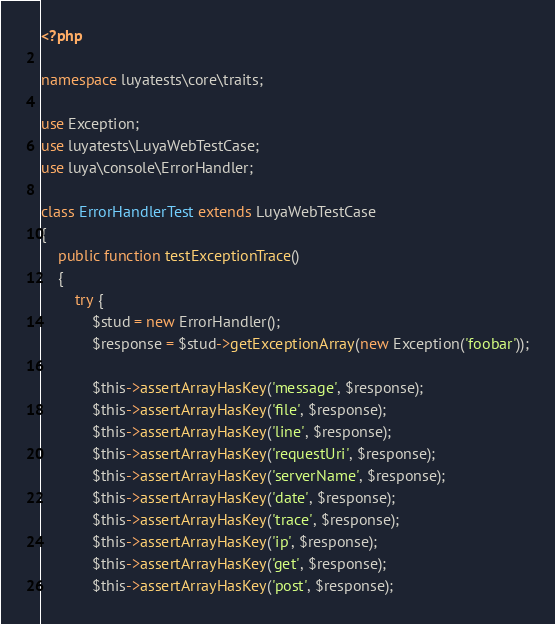Convert code to text. <code><loc_0><loc_0><loc_500><loc_500><_PHP_><?php

namespace luyatests\core\traits;

use Exception;
use luyatests\LuyaWebTestCase;
use luya\console\ErrorHandler;

class ErrorHandlerTest extends LuyaWebTestCase
{
    public function testExceptionTrace()
    {
        try {
            $stud = new ErrorHandler();
            $response = $stud->getExceptionArray(new Exception('foobar'));
            
            $this->assertArrayHasKey('message', $response);
            $this->assertArrayHasKey('file', $response);
            $this->assertArrayHasKey('line', $response);
            $this->assertArrayHasKey('requestUri', $response);
            $this->assertArrayHasKey('serverName', $response);
            $this->assertArrayHasKey('date', $response);
            $this->assertArrayHasKey('trace', $response);
            $this->assertArrayHasKey('ip', $response);
            $this->assertArrayHasKey('get', $response);
            $this->assertArrayHasKey('post', $response);</code> 